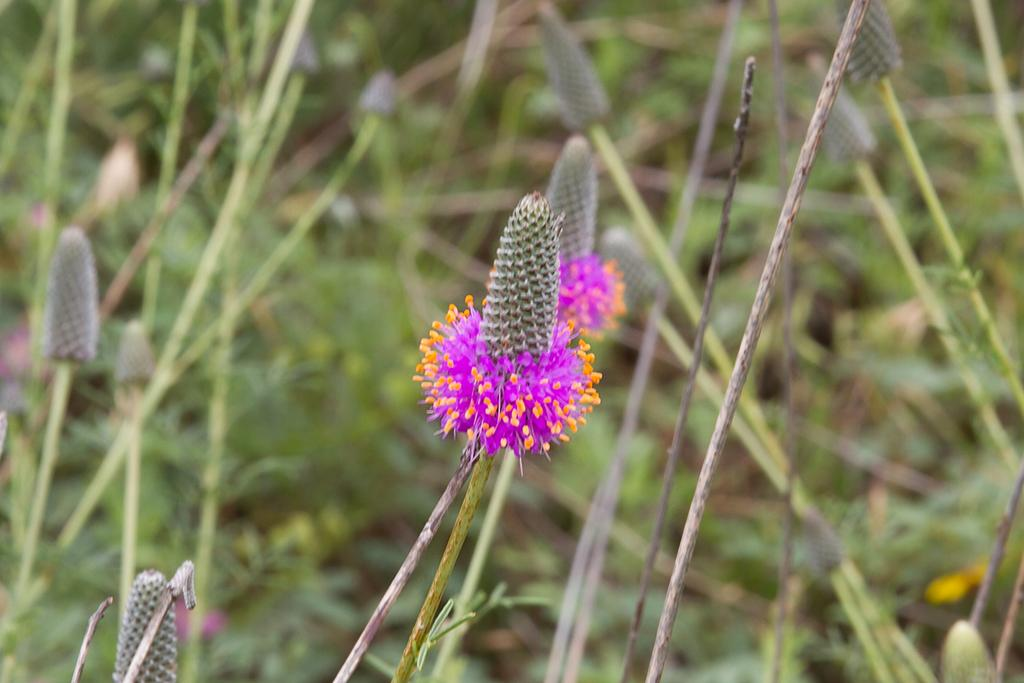What type of plants can be seen in the image? There are flowers and leaves in the image. What can be inferred about the focus of the image? The background of the image is blurred, suggesting that the flowers and leaves are the main focus. What type of news can be read on the calculator in the image? There is no calculator present in the image, so it is not possible to read any news on it. 